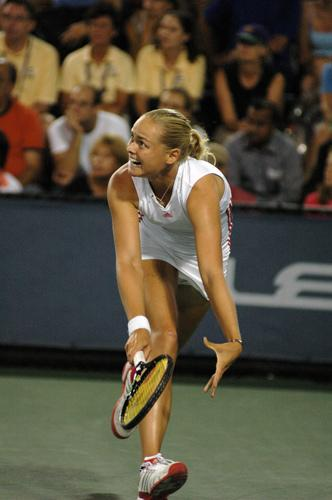What move is this female player making? Please explain your reasoning. receive. The move is to receive. 